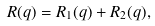<formula> <loc_0><loc_0><loc_500><loc_500>R ( q ) = R _ { 1 } ( q ) + R _ { 2 } ( q ) ,</formula> 